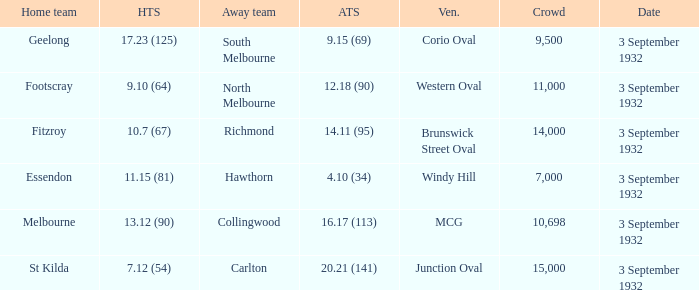What date is listed for the team that has an Away team score of 20.21 (141)? 3 September 1932. 